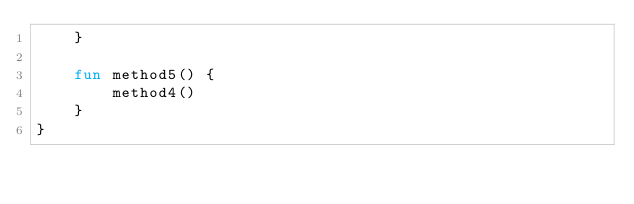<code> <loc_0><loc_0><loc_500><loc_500><_Kotlin_>    }

    fun method5() {
        method4()
    }
}
</code> 